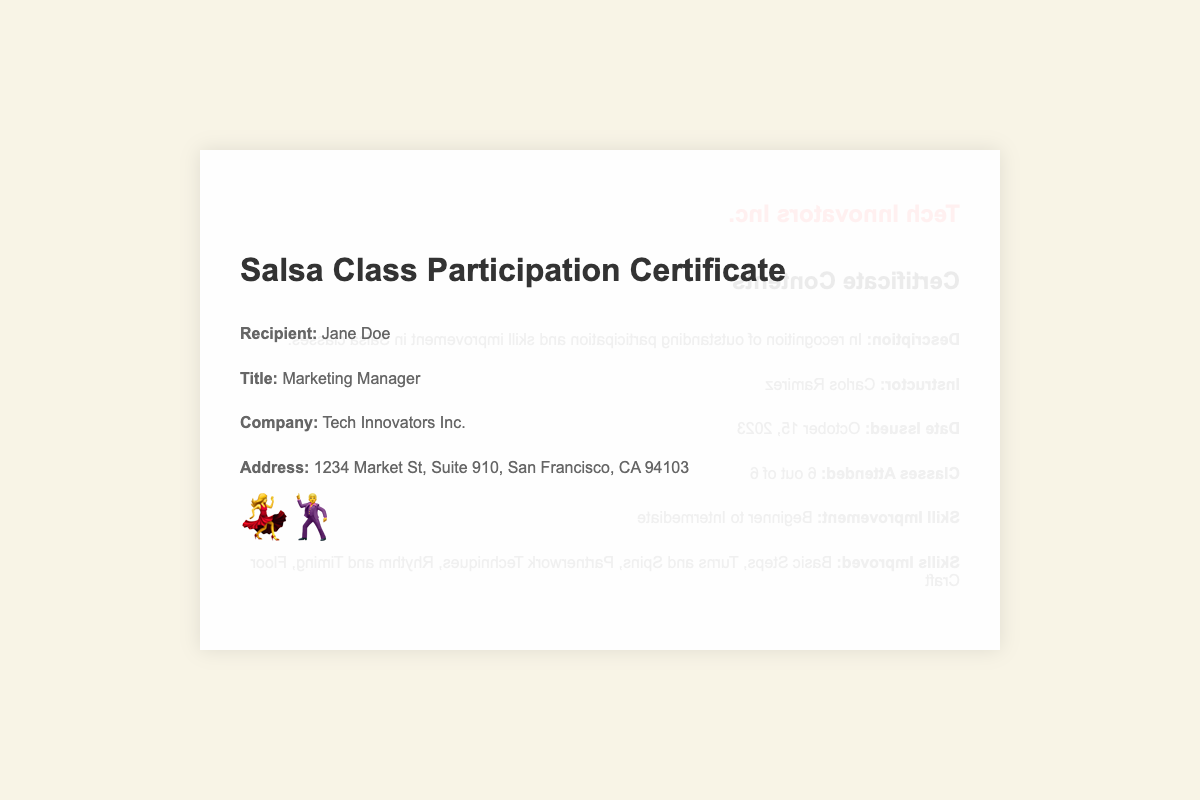what is the name of the recipient? The document clearly states the recipient's name, which is the individual being awarded the certificate.
Answer: Jane Doe what title does the recipient hold? The title of the recipient is mentioned in the document, showing their position in the company.
Answer: Marketing Manager who is the instructor of the salsa classes? The document provides the name of the instructor who taught the salsa classes attended by the recipient.
Answer: Carlos Ramirez how many classes were attended? The number of classes attended is specified in the document, representing the recipient's participation level.
Answer: 6 what was the date the certificate was issued? The date of issue indicates when the recognition was formally granted, which is provided in the document.
Answer: October 15, 2023 what was the skill improvement level achieved by the recipient? The document outlines the progression of skills acquired by the recipient after attending the classes.
Answer: Intermediate what has improved in the recipient's skills? The certificate lists the specific skills that showed improvement during the salsa classes attended by the recipient.
Answer: Basic Steps, Turns and Spins, Partnerwork Techniques, Rhythm and Timing, Floor Craft what type of document is this? The overall information depicted in the document reveals what type of formal recognition is being given to the recipient.
Answer: Participation Certificate 